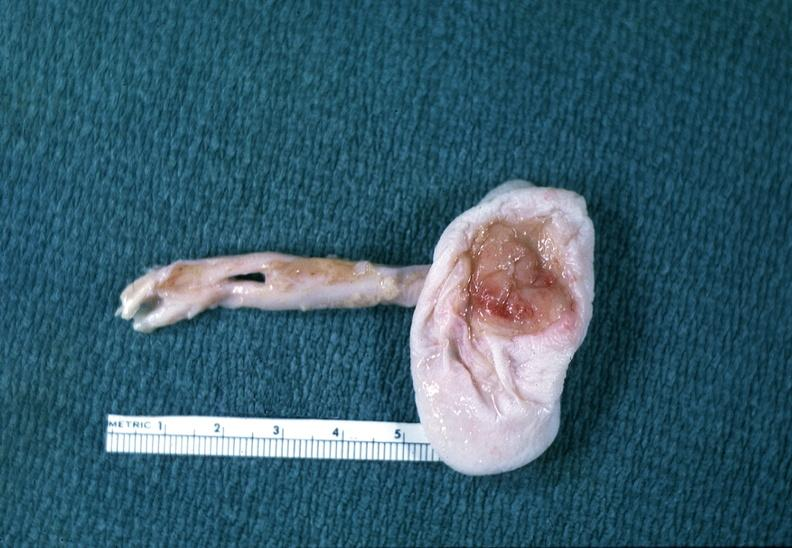does acute myelogenous leukemia show neural tube defect?
Answer the question using a single word or phrase. No 